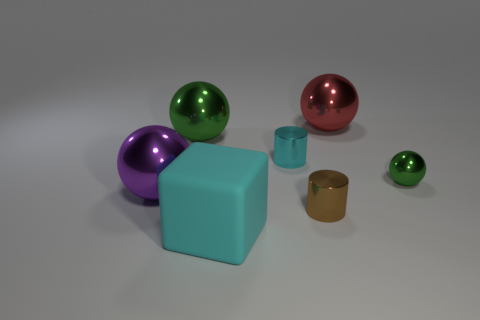Is the brown metallic cylinder the same size as the red object?
Provide a short and direct response. No. Are there any large things behind the big cyan object?
Ensure brevity in your answer.  Yes. There is a ball that is both behind the purple metallic ball and left of the cyan shiny object; how big is it?
Keep it short and to the point. Large. What number of objects are either blue rubber things or cyan metallic objects?
Your response must be concise. 1. Is the size of the rubber block the same as the green shiny thing that is behind the small cyan cylinder?
Keep it short and to the point. Yes. There is a green sphere on the right side of the green metal thing that is on the left side of the big cube left of the cyan cylinder; what is its size?
Offer a terse response. Small. Are any big metallic spheres visible?
Offer a terse response. Yes. What is the material of the other ball that is the same color as the small shiny sphere?
Ensure brevity in your answer.  Metal. How many metallic objects have the same color as the block?
Your answer should be compact. 1. How many things are either big balls behind the large purple ball or large red objects that are to the right of the big rubber block?
Your response must be concise. 2. 